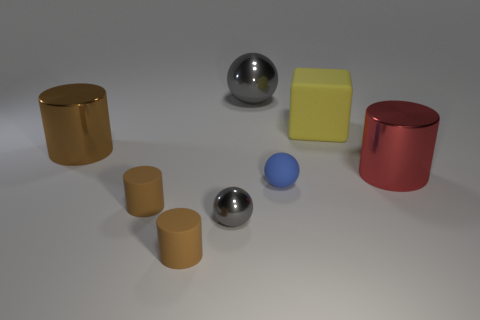Are there an equal number of small brown things in front of the large yellow matte cube and gray metal things that are to the left of the small blue object?
Provide a short and direct response. Yes. Is there a brown matte cylinder of the same size as the red cylinder?
Offer a terse response. No. What size is the blue thing?
Offer a very short reply. Small. Are there an equal number of things behind the big red metal cylinder and big metal objects?
Offer a very short reply. Yes. How many other things are the same color as the tiny metallic thing?
Keep it short and to the point. 1. The thing that is both in front of the yellow cube and behind the red metallic cylinder is what color?
Give a very brief answer. Brown. What size is the gray object behind the large red metal object behind the metal object in front of the red shiny cylinder?
Offer a terse response. Large. How many things are gray shiny balls behind the large matte cube or shiny cylinders to the right of the large brown shiny object?
Keep it short and to the point. 2. What is the shape of the tiny blue rubber object?
Provide a short and direct response. Sphere. What number of other objects are the same material as the large yellow cube?
Ensure brevity in your answer.  3. 